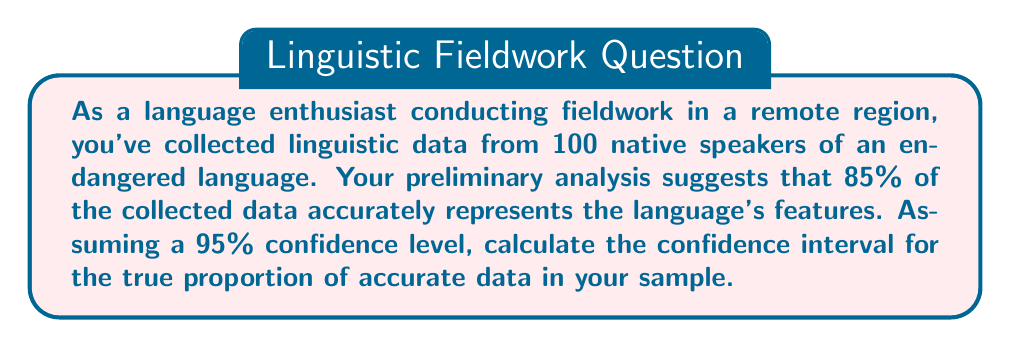Help me with this question. To calculate the confidence interval for a proportion, we'll use the formula:

$$ CI = \hat{p} \pm z \sqrt{\frac{\hat{p}(1-\hat{p})}{n}} $$

Where:
$\hat{p}$ = sample proportion
$z$ = z-score for the desired confidence level
$n$ = sample size

1. Given information:
   $\hat{p} = 0.85$ (85% accuracy)
   $n = 100$ (sample size)
   Confidence level = 95% (z-score = 1.96)

2. Calculate the margin of error:
   $$ ME = z \sqrt{\frac{\hat{p}(1-\hat{p})}{n}} $$
   $$ ME = 1.96 \sqrt{\frac{0.85(1-0.85)}{100}} $$
   $$ ME = 1.96 \sqrt{\frac{0.1275}{100}} $$
   $$ ME = 1.96 \sqrt{0.001275} $$
   $$ ME = 1.96 \times 0.0357 $$
   $$ ME = 0.07 $$

3. Calculate the confidence interval:
   $$ CI = \hat{p} \pm ME $$
   $$ CI = 0.85 \pm 0.07 $$
   $$ CI = [0.78, 0.92] $$

Therefore, we can be 95% confident that the true proportion of accurate linguistic data in our sample falls between 0.78 (78%) and 0.92 (92%).
Answer: The 95% confidence interval for the true proportion of accurate linguistic data is [0.78, 0.92] or 78% to 92%. 